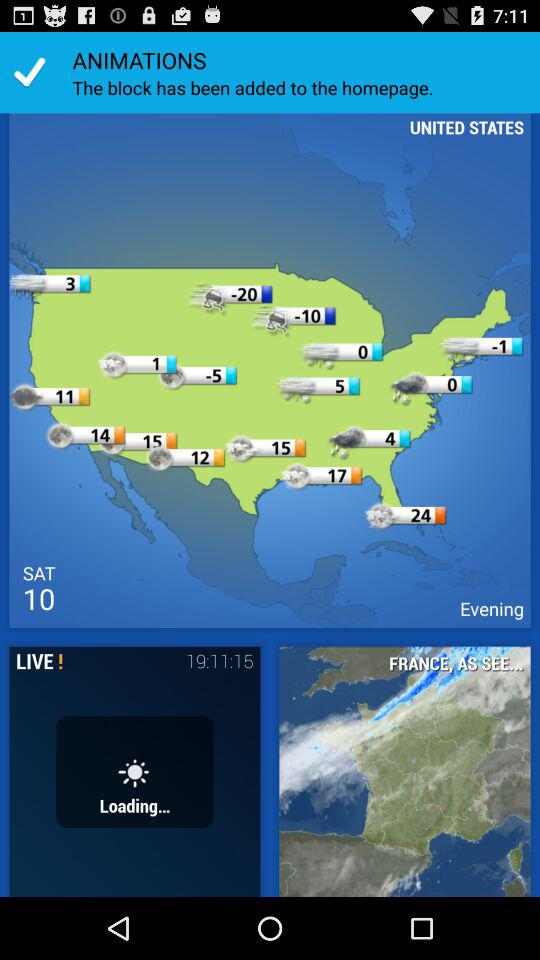What is the mentioned country? The mentioned countries are the United States and France. 